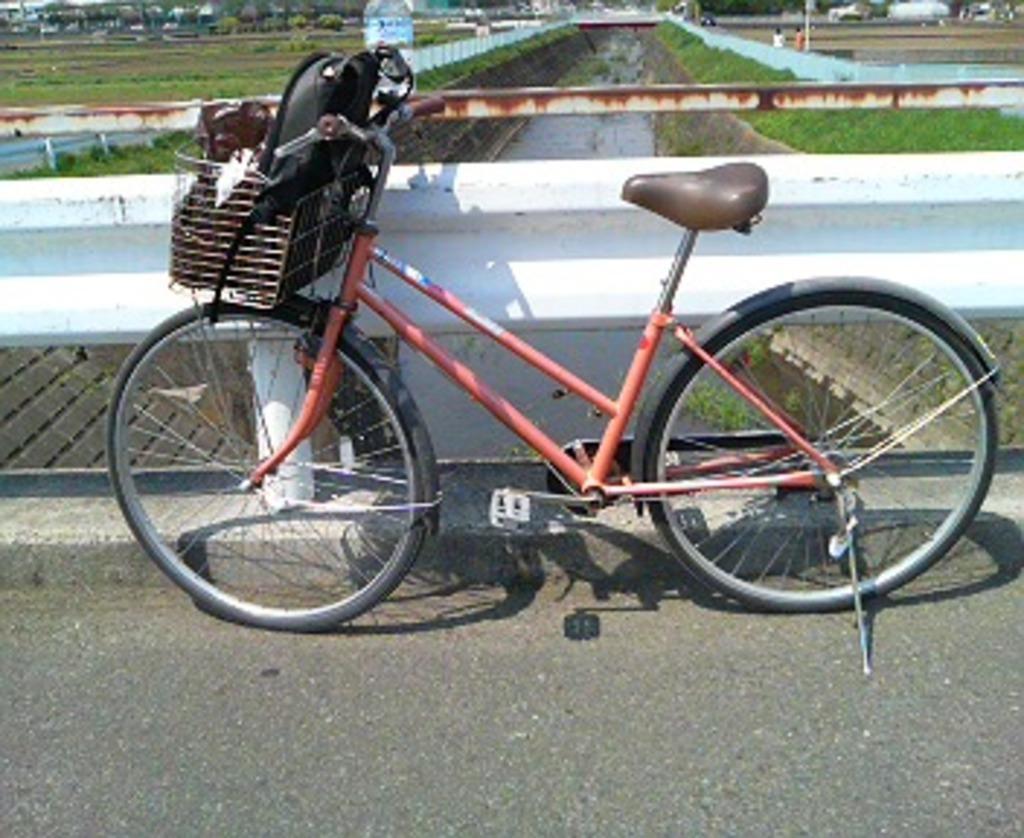Describe this image in one or two sentences. There is a cycle with a basket. Inside the basket there is a bag and some other thing. Near to the cycle there is a wall. In the back there is water and plants. 